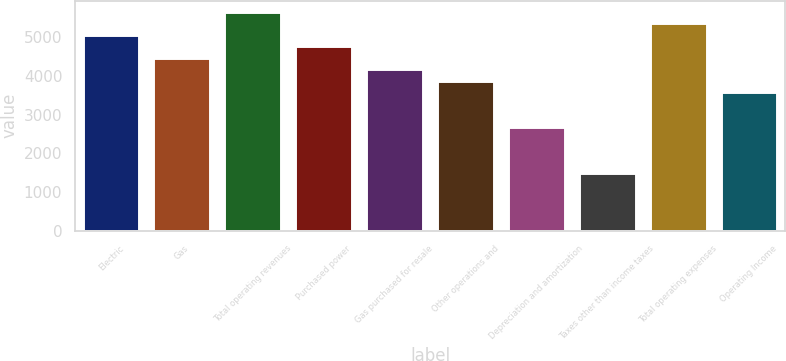Convert chart. <chart><loc_0><loc_0><loc_500><loc_500><bar_chart><fcel>Electric<fcel>Gas<fcel>Total operating revenues<fcel>Purchased power<fcel>Gas purchased for resale<fcel>Other operations and<fcel>Depreciation and amortization<fcel>Taxes other than income taxes<fcel>Total operating expenses<fcel>Operating Income<nl><fcel>5071.4<fcel>4475<fcel>5667.8<fcel>4773.2<fcel>4176.8<fcel>3878.6<fcel>2685.8<fcel>1493<fcel>5369.6<fcel>3580.4<nl></chart> 